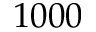<formula> <loc_0><loc_0><loc_500><loc_500>1 0 0 0</formula> 